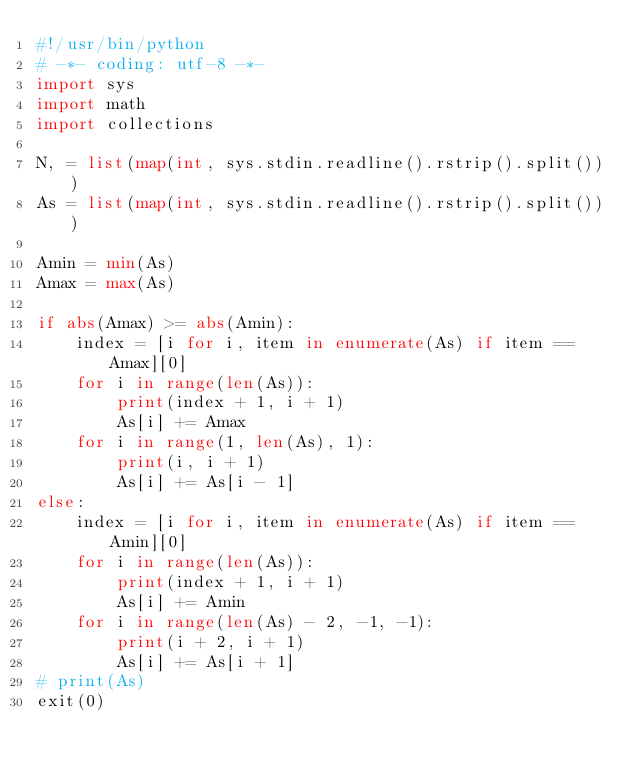Convert code to text. <code><loc_0><loc_0><loc_500><loc_500><_Python_>#!/usr/bin/python
# -*- coding: utf-8 -*-
import sys
import math
import collections

N, = list(map(int, sys.stdin.readline().rstrip().split()))
As = list(map(int, sys.stdin.readline().rstrip().split()))

Amin = min(As)
Amax = max(As)

if abs(Amax) >= abs(Amin):
    index = [i for i, item in enumerate(As) if item == Amax][0]
    for i in range(len(As)):
        print(index + 1, i + 1)
        As[i] += Amax
    for i in range(1, len(As), 1):
        print(i, i + 1)
        As[i] += As[i - 1]
else:
    index = [i for i, item in enumerate(As) if item == Amin][0]
    for i in range(len(As)):
        print(index + 1, i + 1)
        As[i] += Amin
    for i in range(len(As) - 2, -1, -1):
        print(i + 2, i + 1)
        As[i] += As[i + 1]
# print(As)
exit(0)
</code> 